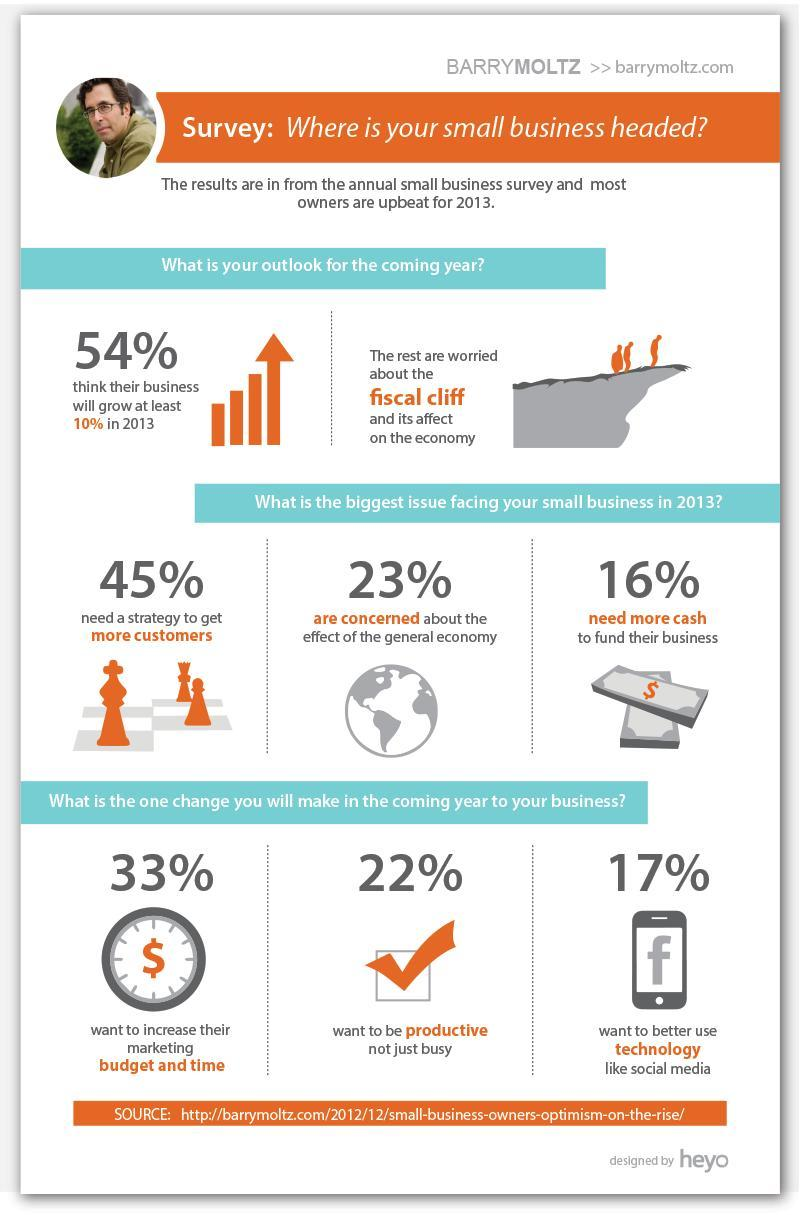What percent thinks that their business will not grow by at least 10%?
Answer the question with a short phrase. 46% What is the biggest change to be made? increase marketing budget and time 